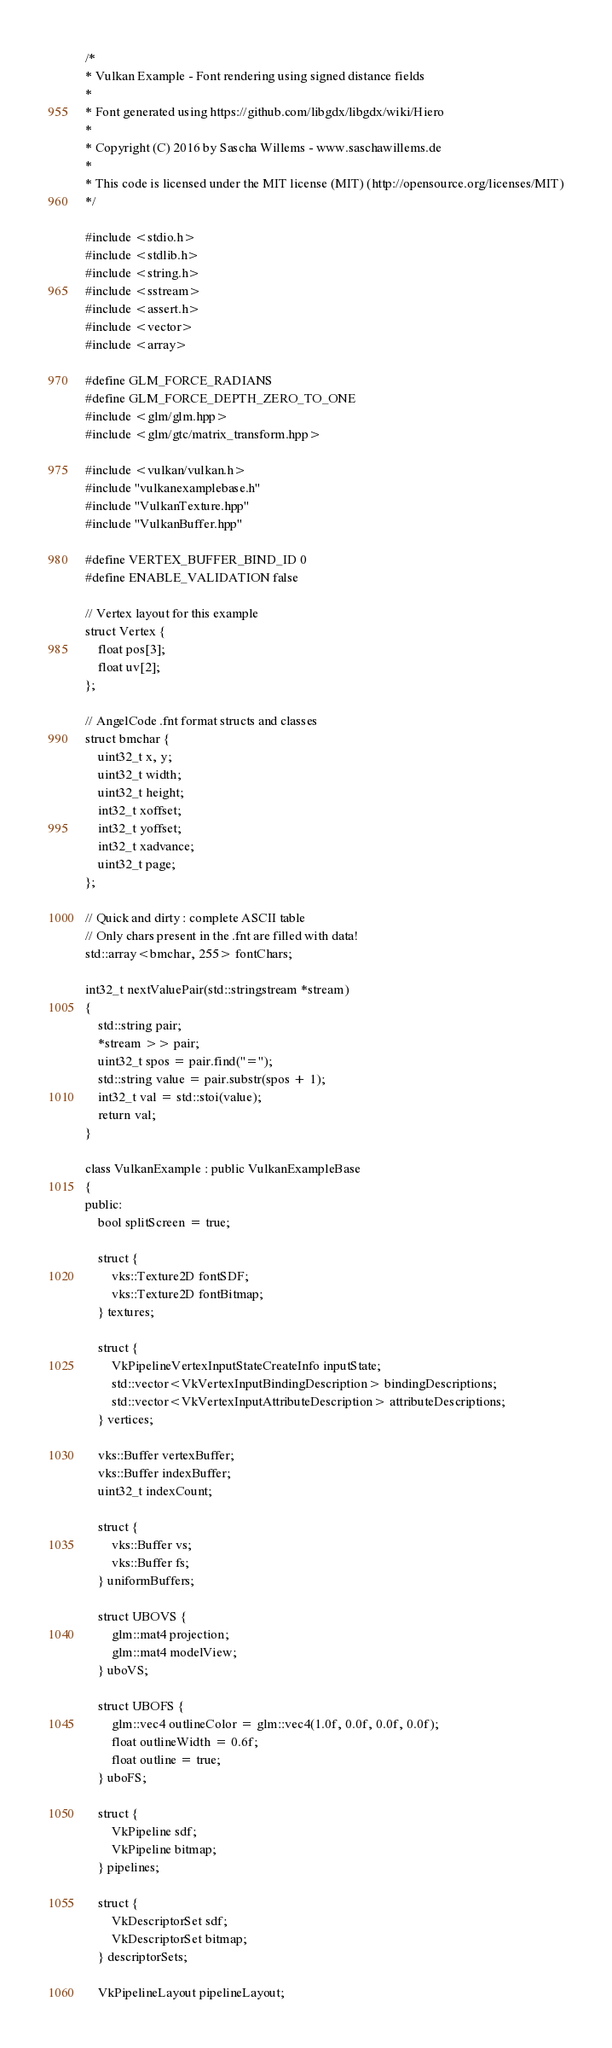<code> <loc_0><loc_0><loc_500><loc_500><_C++_>/*
* Vulkan Example - Font rendering using signed distance fields
*
* Font generated using https://github.com/libgdx/libgdx/wiki/Hiero
*
* Copyright (C) 2016 by Sascha Willems - www.saschawillems.de
*
* This code is licensed under the MIT license (MIT) (http://opensource.org/licenses/MIT)
*/

#include <stdio.h>
#include <stdlib.h>
#include <string.h>
#include <sstream>
#include <assert.h>
#include <vector>
#include <array>

#define GLM_FORCE_RADIANS
#define GLM_FORCE_DEPTH_ZERO_TO_ONE
#include <glm/glm.hpp>
#include <glm/gtc/matrix_transform.hpp>

#include <vulkan/vulkan.h>
#include "vulkanexamplebase.h"
#include "VulkanTexture.hpp"
#include "VulkanBuffer.hpp"

#define VERTEX_BUFFER_BIND_ID 0
#define ENABLE_VALIDATION false

// Vertex layout for this example
struct Vertex {
	float pos[3];
	float uv[2];
};

// AngelCode .fnt format structs and classes
struct bmchar {
	uint32_t x, y;
	uint32_t width;
	uint32_t height;
	int32_t xoffset;
	int32_t yoffset;
	int32_t xadvance;
	uint32_t page;
};

// Quick and dirty : complete ASCII table
// Only chars present in the .fnt are filled with data!
std::array<bmchar, 255> fontChars;

int32_t nextValuePair(std::stringstream *stream)
{
	std::string pair;
	*stream >> pair;
	uint32_t spos = pair.find("=");
	std::string value = pair.substr(spos + 1);
	int32_t val = std::stoi(value);
	return val;
}

class VulkanExample : public VulkanExampleBase
{
public:
	bool splitScreen = true;

	struct {
		vks::Texture2D fontSDF;
		vks::Texture2D fontBitmap;
	} textures;

	struct {
		VkPipelineVertexInputStateCreateInfo inputState;
		std::vector<VkVertexInputBindingDescription> bindingDescriptions;
		std::vector<VkVertexInputAttributeDescription> attributeDescriptions;
	} vertices;

	vks::Buffer vertexBuffer;
	vks::Buffer indexBuffer;
	uint32_t indexCount;

	struct {
		vks::Buffer vs;
		vks::Buffer fs;
	} uniformBuffers;

	struct UBOVS {
		glm::mat4 projection;
		glm::mat4 modelView;
	} uboVS;

	struct UBOFS {
		glm::vec4 outlineColor = glm::vec4(1.0f, 0.0f, 0.0f, 0.0f);
		float outlineWidth = 0.6f;
		float outline = true;
	} uboFS;

	struct {
		VkPipeline sdf;
		VkPipeline bitmap;
	} pipelines;

	struct {
		VkDescriptorSet sdf;
		VkDescriptorSet bitmap;
	} descriptorSets;

	VkPipelineLayout pipelineLayout;</code> 